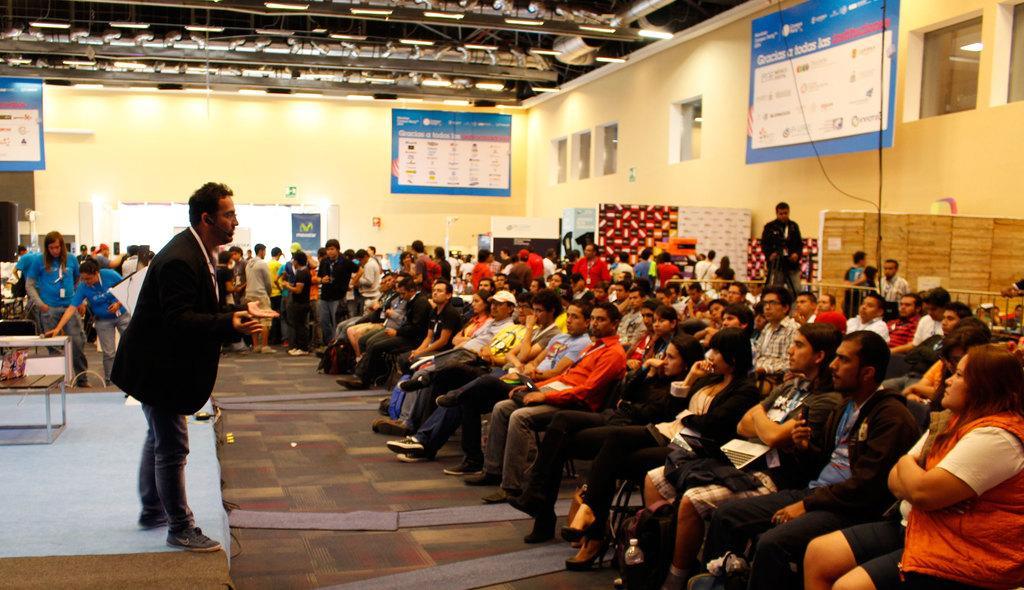How would you summarize this image in a sentence or two? This is the picture of a room. On the left side of image there is a person standing. At the back there are group of people standing. On the right side of the image there are group of people sitting. At the top there are hoardings and lights. On the left side of the image there are objects on the table. At the bottom there are mats. 